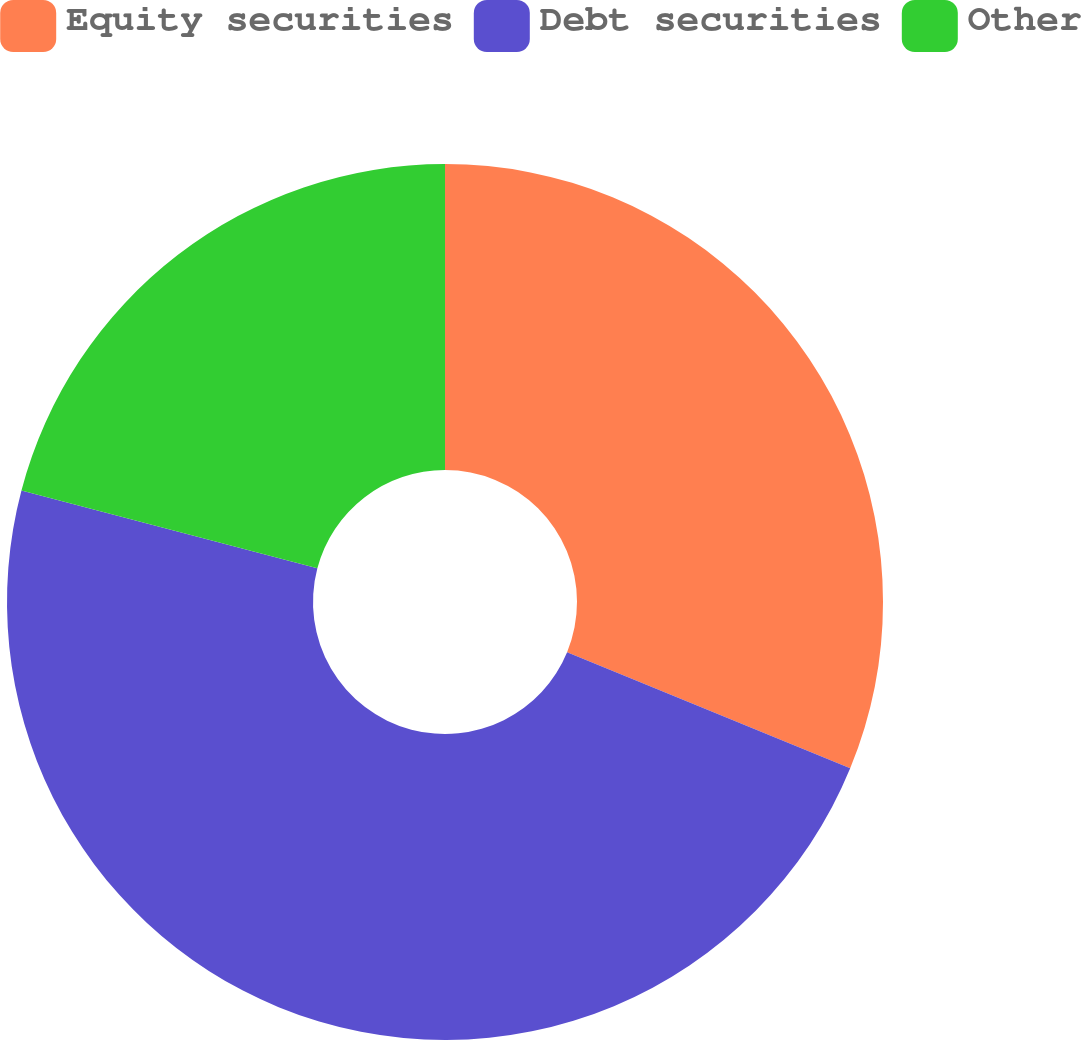Convert chart. <chart><loc_0><loc_0><loc_500><loc_500><pie_chart><fcel>Equity securities<fcel>Debt securities<fcel>Other<nl><fcel>31.2%<fcel>47.9%<fcel>20.9%<nl></chart> 